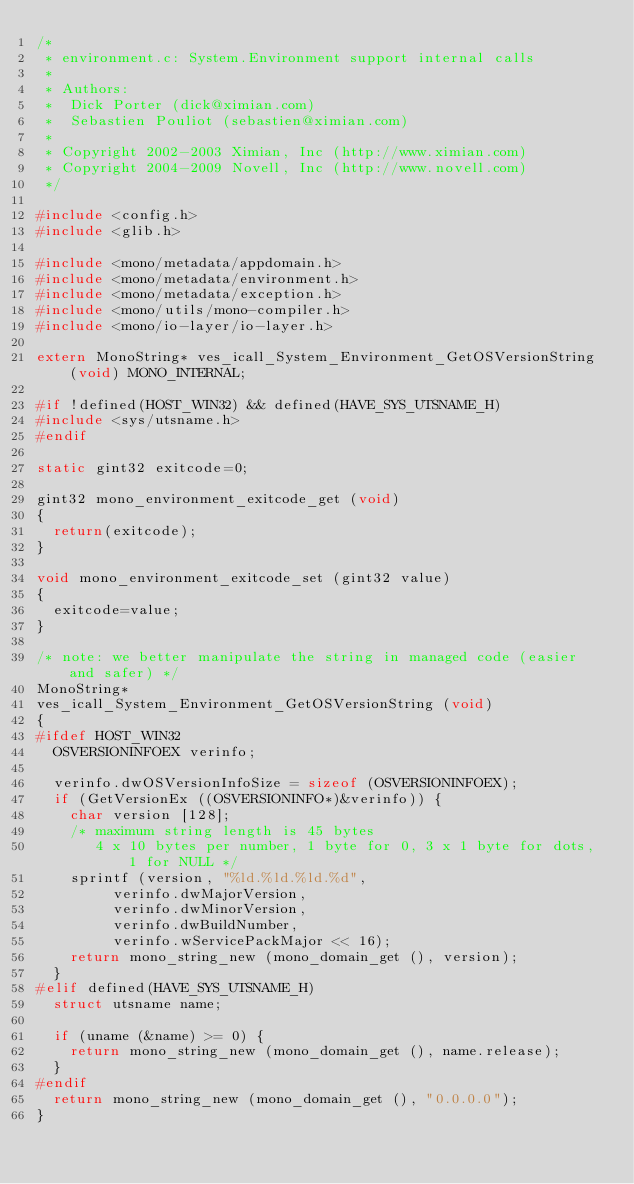<code> <loc_0><loc_0><loc_500><loc_500><_C_>/*
 * environment.c: System.Environment support internal calls
 *
 * Authors:
 *	Dick Porter (dick@ximian.com)
 *	Sebastien Pouliot (sebastien@ximian.com)
 *
 * Copyright 2002-2003 Ximian, Inc (http://www.ximian.com)
 * Copyright 2004-2009 Novell, Inc (http://www.novell.com)
 */

#include <config.h>
#include <glib.h>

#include <mono/metadata/appdomain.h>
#include <mono/metadata/environment.h>
#include <mono/metadata/exception.h>
#include <mono/utils/mono-compiler.h>
#include <mono/io-layer/io-layer.h>

extern MonoString* ves_icall_System_Environment_GetOSVersionString (void) MONO_INTERNAL;

#if !defined(HOST_WIN32) && defined(HAVE_SYS_UTSNAME_H)
#include <sys/utsname.h>
#endif

static gint32 exitcode=0;

gint32 mono_environment_exitcode_get (void)
{
	return(exitcode);
}

void mono_environment_exitcode_set (gint32 value)
{
	exitcode=value;
}

/* note: we better manipulate the string in managed code (easier and safer) */
MonoString*
ves_icall_System_Environment_GetOSVersionString (void)
{
#ifdef HOST_WIN32
	OSVERSIONINFOEX verinfo;

	verinfo.dwOSVersionInfoSize = sizeof (OSVERSIONINFOEX);
	if (GetVersionEx ((OSVERSIONINFO*)&verinfo)) {
		char version [128];
		/* maximum string length is 45 bytes
		   4 x 10 bytes per number, 1 byte for 0, 3 x 1 byte for dots, 1 for NULL */
		sprintf (version, "%ld.%ld.%ld.%d",
				 verinfo.dwMajorVersion,
				 verinfo.dwMinorVersion,
				 verinfo.dwBuildNumber,
				 verinfo.wServicePackMajor << 16);
		return mono_string_new (mono_domain_get (), version);
	}
#elif defined(HAVE_SYS_UTSNAME_H)
	struct utsname name;

	if (uname (&name) >= 0) {
		return mono_string_new (mono_domain_get (), name.release);
	}
#endif
	return mono_string_new (mono_domain_get (), "0.0.0.0");
}

</code> 